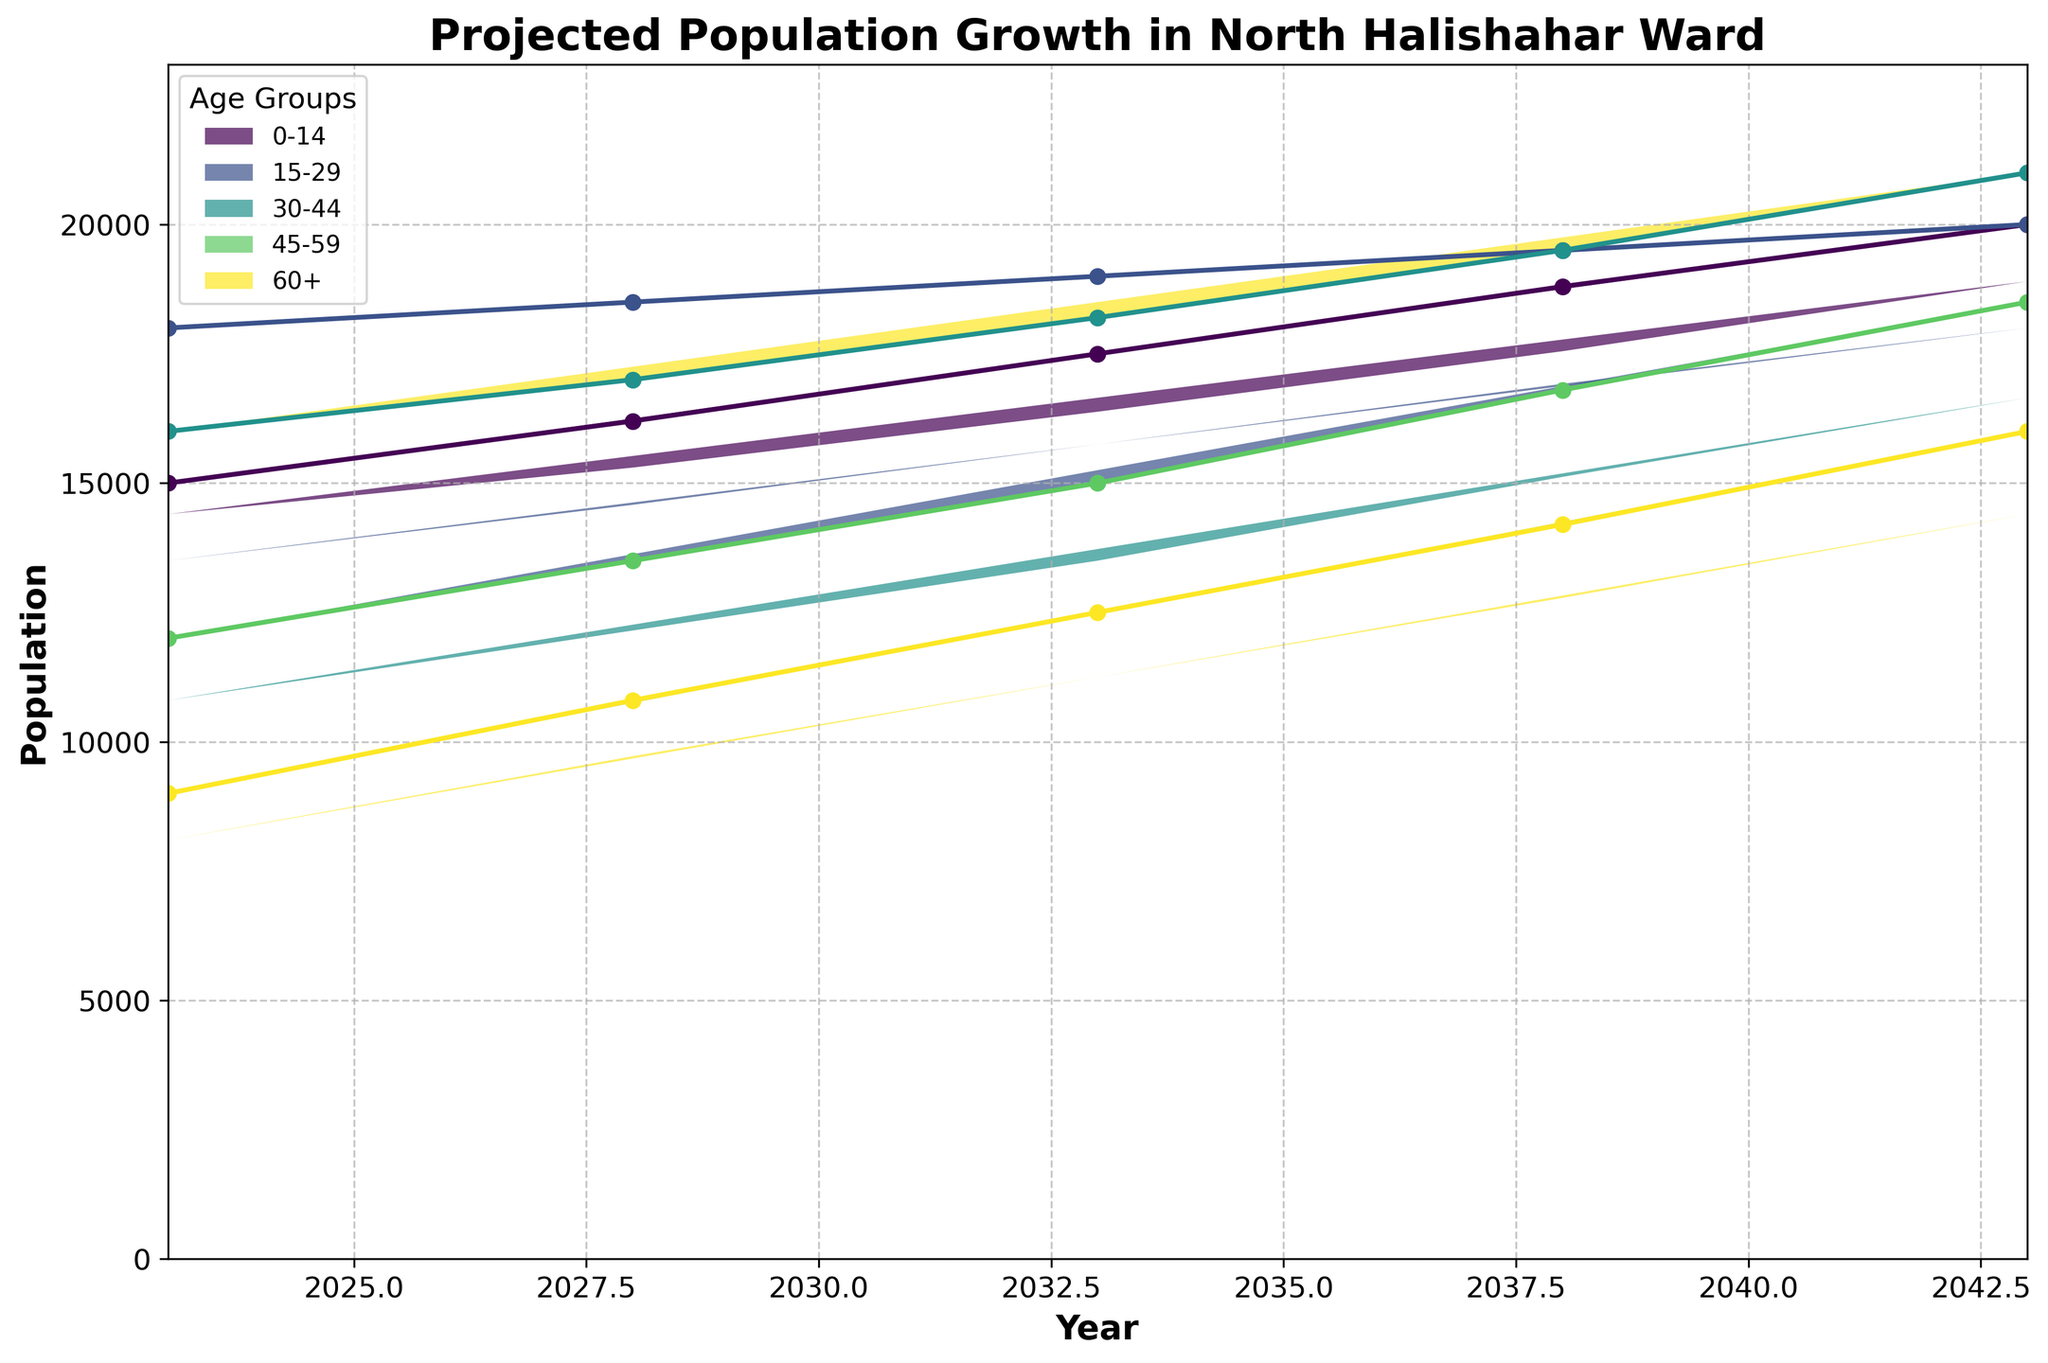What is the projected population of the 0-14 age group in 2043? Look at the '0-14' category for the year 2043 on the x-axis. The value is 20,000.
Answer: 20,000 How many age groups are projected in this fan chart? Count the different lines (or areas) representing different age groups. There are five: '0-14', '15-29', '30-44', '45-59', '60+'.
Answer: 5 Which age group is projected to have the highest population in 2043? Compare the values for each age group in the year 2043. The '30-44' age group has the highest population at 21,000.
Answer: 30-44 How much is the projected population increase for the 60+ age group from 2023 to 2043? Subtract the 2023 value (9,000) from the 2043 value (16,000) for the '60+' age group. So, 16,000 - 9,000 = 7,000.
Answer: 7,000 Which age group shows the least growth between 2023 and 2043? Calculate the difference for each age group between 2043 and 2023. The '15-29' group goes from 18,000 to 20,000, an increase of 2,000, which is the smallest increase.
Answer: 15-29 What is the projected total population of the 0-14 and 15-29 age groups combined in 2028? Sum the 2028 values for '0-14' (16,200) and '15-29' (18,500). Therefore, 16,200 + 18,500 = 34,700.
Answer: 34,700 How does the projected population of the 45-59 age group change between 2033 and 2038? Subtract the 2033 value (15,000) from the 2038 value (16,800). So, 16,800 - 15,000 = 1,800.
Answer: 1,800 Which age group is projected to surpass 15,000 first, 45-59 or 60+? Look at the year values for '45-59' and '60+' groups when they surpass 15,000. The '45-59' group surpasses it in 2038, while '60+' does in 2043. '45-59' does first.
Answer: 45-59 Is the projected growth for the ‘30-44’ age group always increasing between 2023 and 2043? Check the values for '30-44' at each year. The values are: 16,000 (2023), 17,000 (2028), 18,200 (2033), 19,500 (2038), 21,000 (2043). They are consistently increasing.
Answer: Yes 